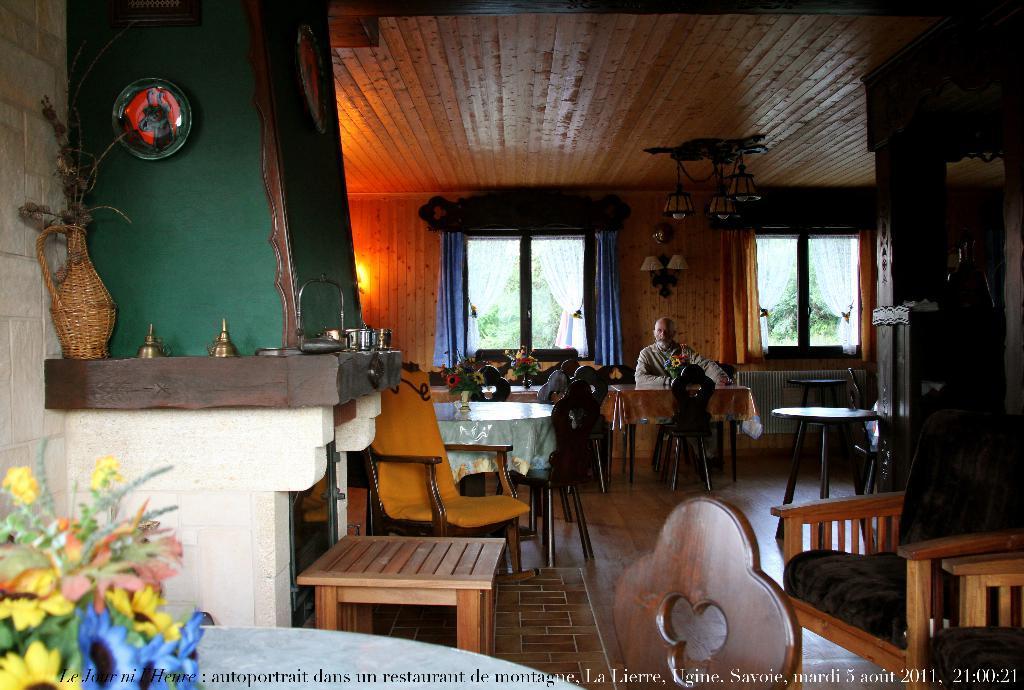Describe this image in one or two sentences. This image is clicked inside a room. There are tables and chairs in the image. There are flower vases on the tables. There is a man sitting on the chair. Behind him there is a wall. There are glass windows to the wall. There are curtains to the windows. There are lights hanging to the ceiling. There are wall lamps on the wall. To the left there are a few objects on the table. In front of it there is a stool. At the bottom there is text on the image. 